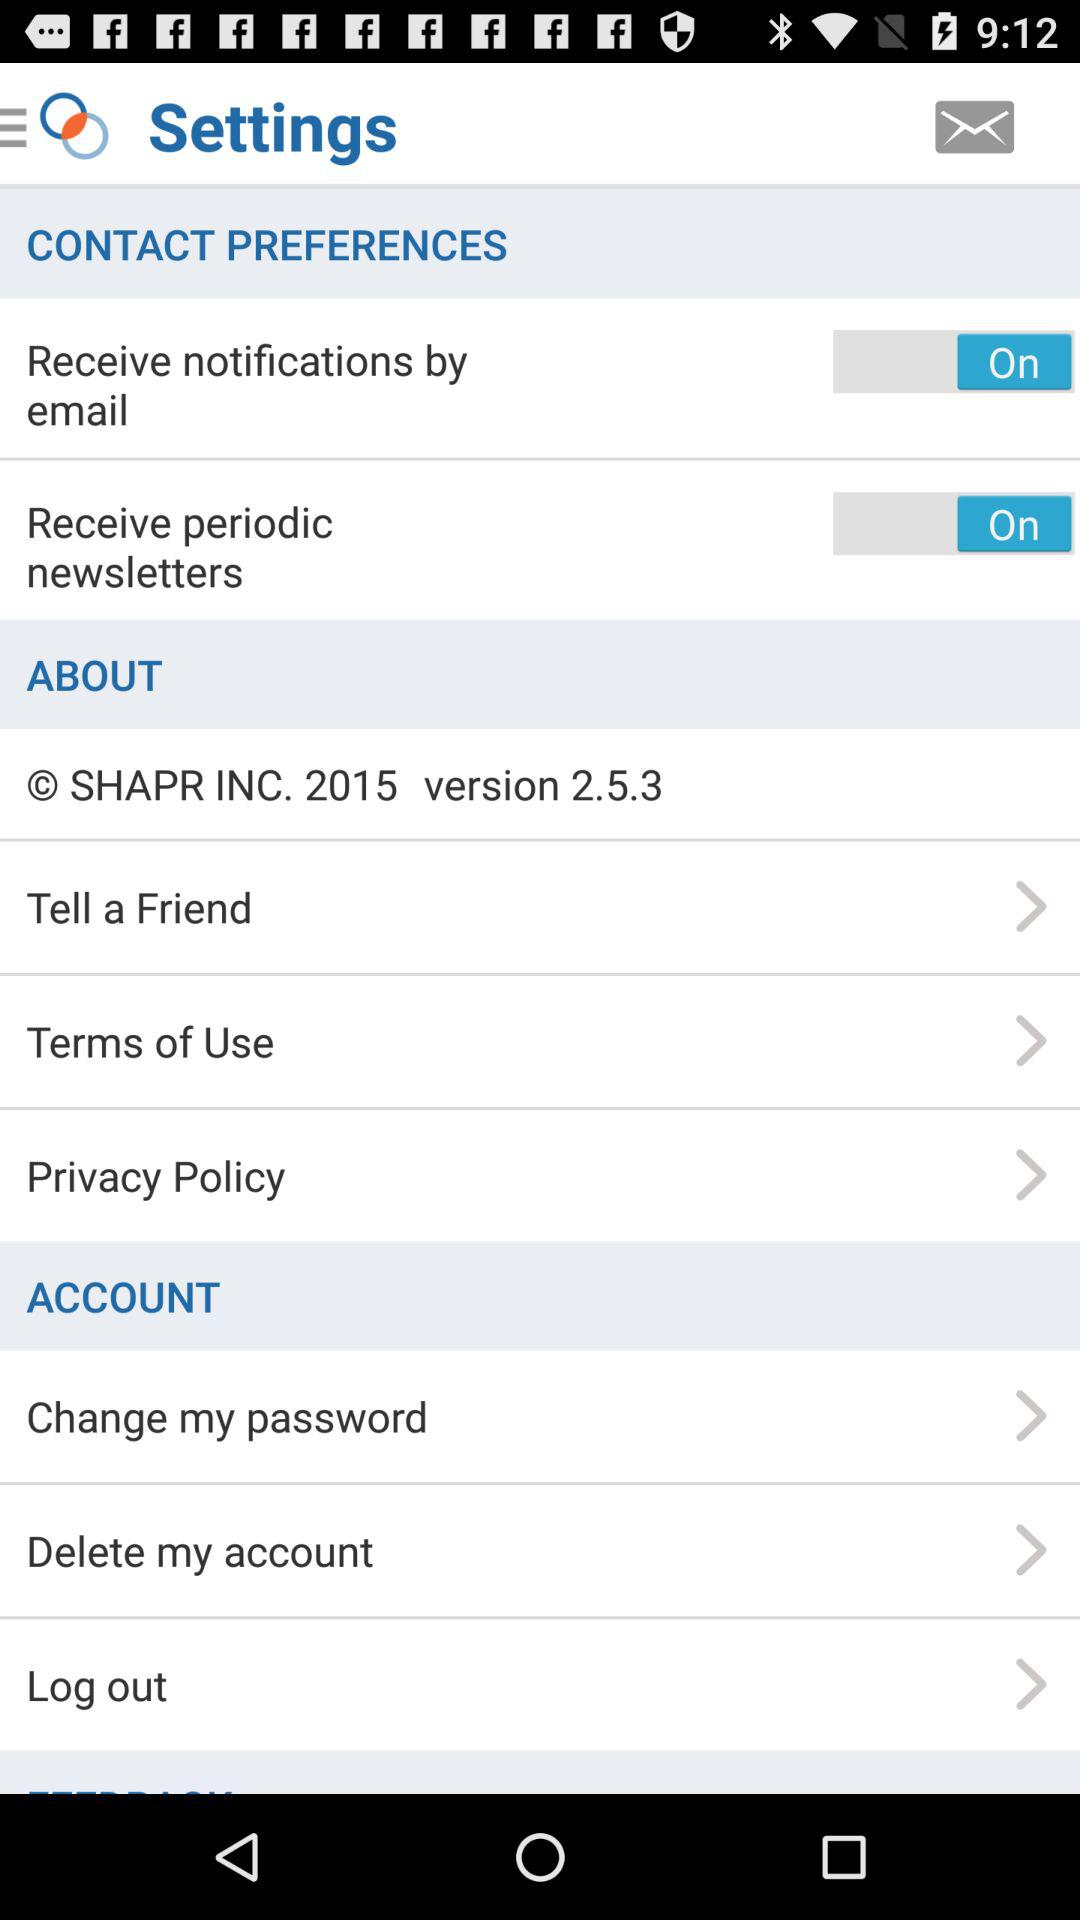What is the copyright year? The copyright year is 2015. 